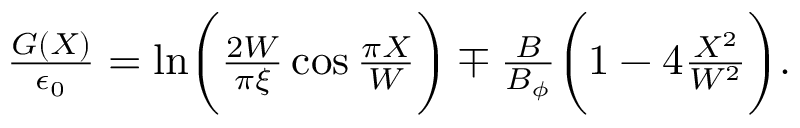Convert formula to latex. <formula><loc_0><loc_0><loc_500><loc_500>\begin{array} { r } { \frac { G ( X ) } { \epsilon _ { 0 } } = \ln \left ( \frac { 2 W } { \pi \xi } \cos \frac { \pi X } { W } \right ) \mp \frac { B } { B _ { \phi } } \left ( 1 - 4 \frac { X ^ { 2 } } { W ^ { 2 } } \right ) . } \end{array}</formula> 